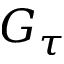Convert formula to latex. <formula><loc_0><loc_0><loc_500><loc_500>G _ { \tau }</formula> 